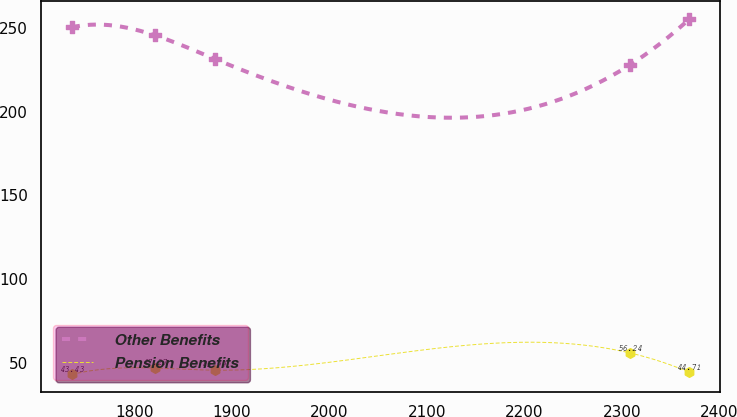Convert chart to OTSL. <chart><loc_0><loc_0><loc_500><loc_500><line_chart><ecel><fcel>Other Benefits<fcel>Pension Benefits<nl><fcel>1735.78<fcel>250.18<fcel>43.43<nl><fcel>1821.28<fcel>245.33<fcel>47.27<nl><fcel>1882.12<fcel>231.36<fcel>45.99<nl><fcel>2308.22<fcel>227.79<fcel>56.24<nl><fcel>2369.06<fcel>255.04<fcel>44.71<nl></chart> 